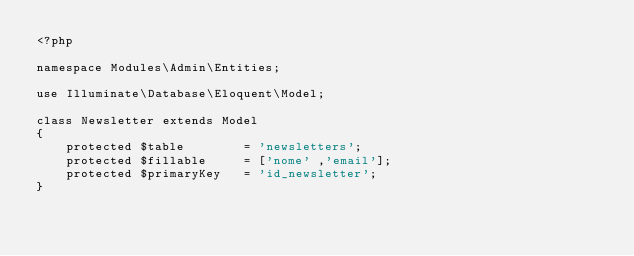Convert code to text. <code><loc_0><loc_0><loc_500><loc_500><_PHP_><?php

namespace Modules\Admin\Entities;

use Illuminate\Database\Eloquent\Model;

class Newsletter extends Model
{
    protected $table        = 'newsletters';
    protected $fillable     = ['nome' ,'email'];
    protected $primaryKey   = 'id_newsletter';
}
</code> 